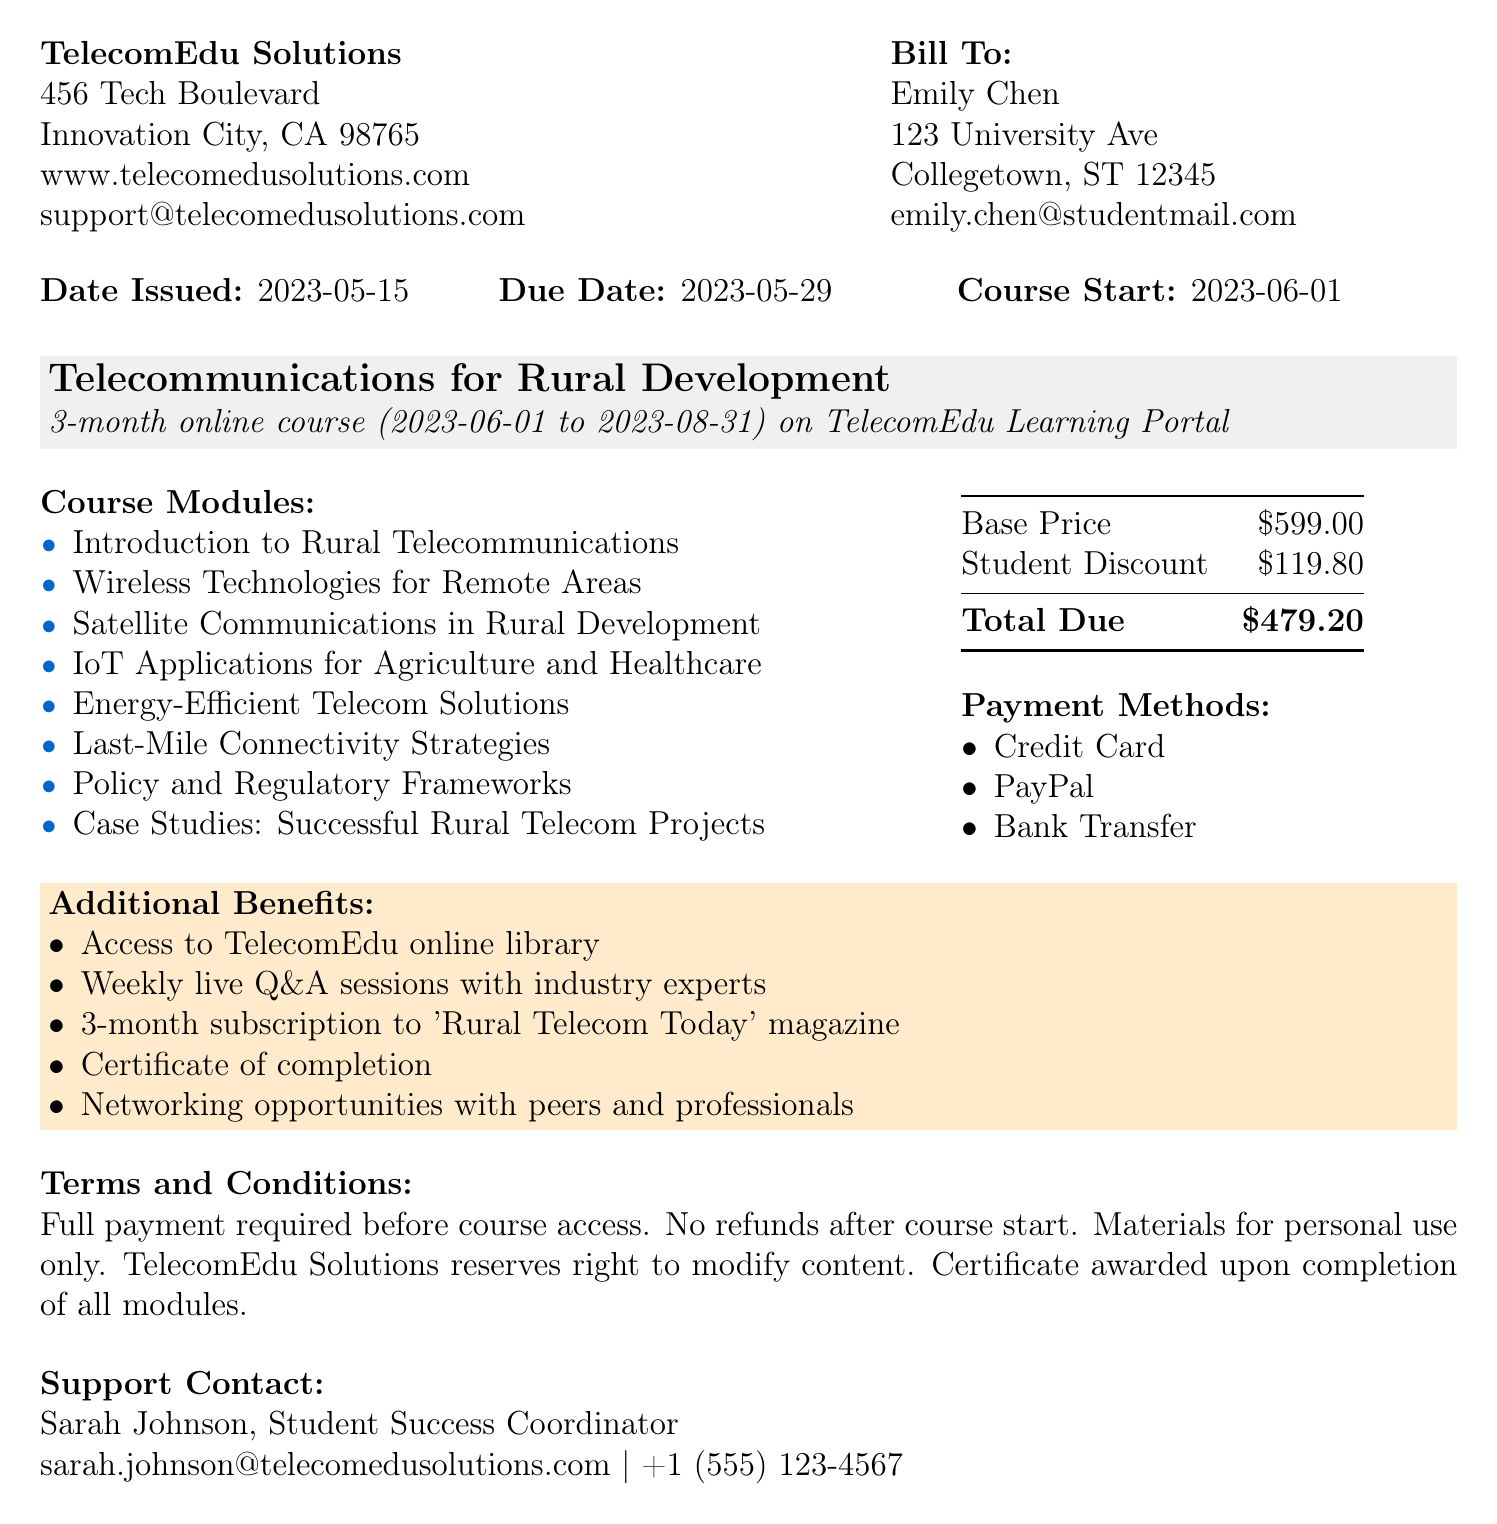What is the invoice number? The invoice number is clearly stated at the top of the document as INV-2023-0542.
Answer: INV-2023-0542 Who is the student enrolled in the course? The document lists the customer's information, mentioning the name Emily Chen as the enrolled student.
Answer: Emily Chen What is the total price of the subscription? The total price reflects the course cost after applying the student discount, shown in the pricing section as $479.20.
Answer: $479.20 When does the course start? The course details section specifies the start date as 2023-06-01.
Answer: 2023-06-01 What are the accepted payment methods? The payment info section outlines the acceptable payment methods, including Credit Card, PayPal, and Bank Transfer.
Answer: Credit Card, PayPal, Bank Transfer How long is the course? The duration of the course is stated in the course details section as 3 months.
Answer: 3 months Who can students contact for support? The support contact section provides the name and details for Sarah Johnson, who is the Student Success Coordinator.
Answer: Sarah Johnson What is one of the additional benefits offered? The document lists several additional benefits, one of which is access to the TelecomEdu online library.
Answer: Access to TelecomEdu online library What is the due date for the invoice payment? The due date is mentioned in the invoice details as 2023-05-29.
Answer: 2023-05-29 